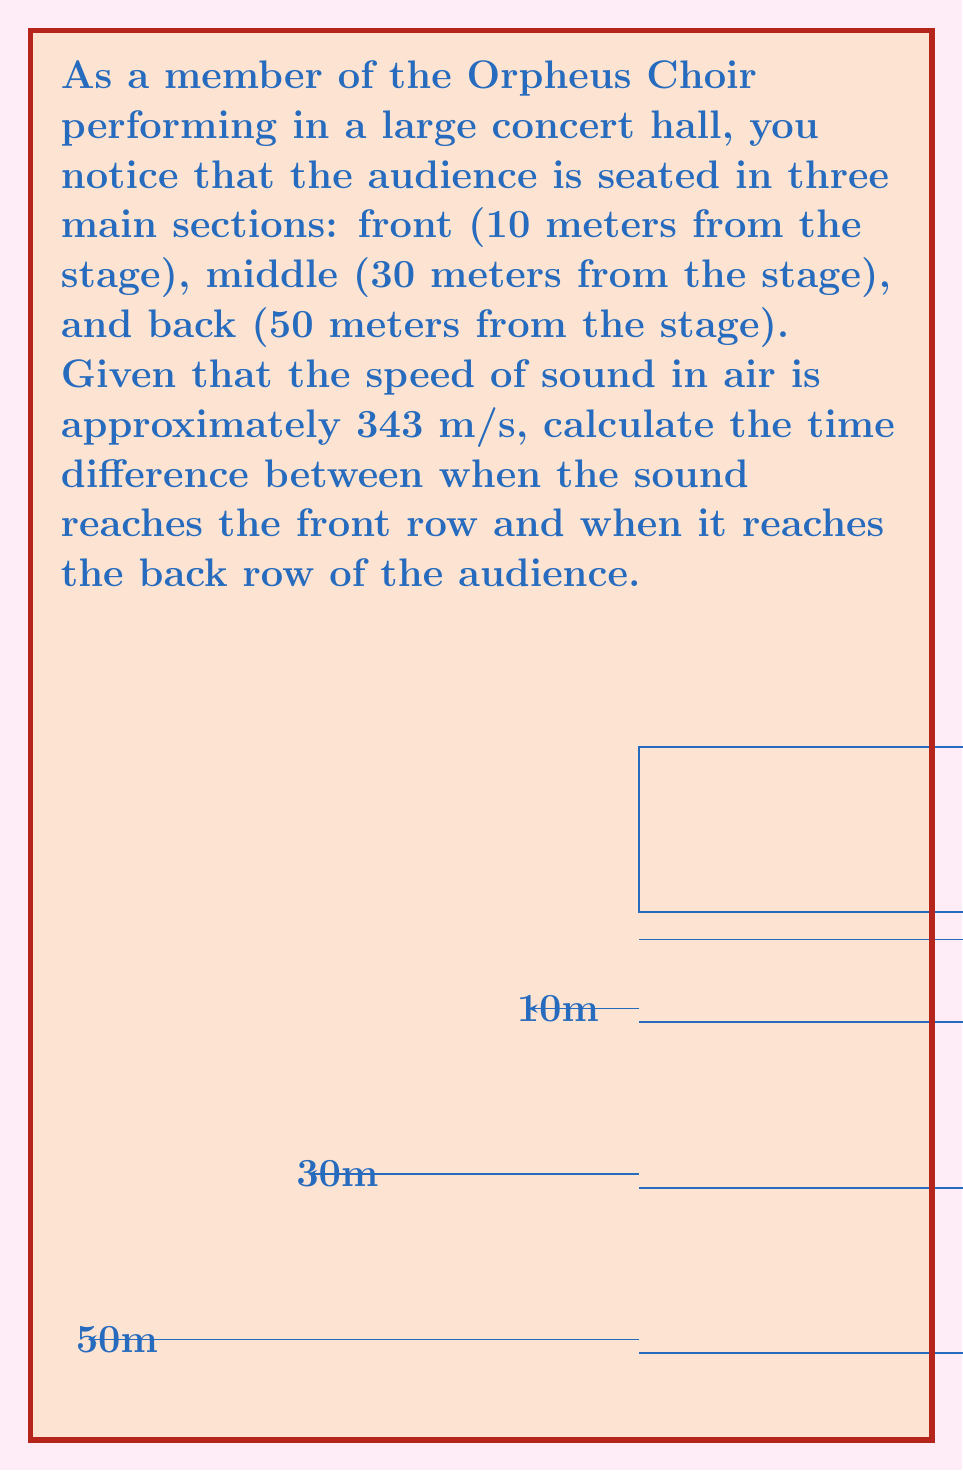Can you solve this math problem? Let's approach this step-by-step:

1) We need to calculate the time it takes for sound to travel from the stage to the back row and subtract the time it takes to reach the front row.

2) The formula for time is: $t = \frac{d}{v}$, where $t$ is time, $d$ is distance, and $v$ is velocity (speed of sound in this case).

3) For the front row:
   $t_{\text{front}} = \frac{10\text{ m}}{343\text{ m/s}} \approx 0.0291\text{ s}$

4) For the back row:
   $t_{\text{back}} = \frac{50\text{ m}}{343\text{ m/s}} \approx 0.1457\text{ s}$

5) The time difference is:
   $\Delta t = t_{\text{back}} - t_{\text{front}} = 0.1457\text{ s} - 0.0291\text{ s} = 0.1166\text{ s}$

6) Converting to milliseconds for a more practical unit:
   $0.1166\text{ s} \times 1000 = 116.6\text{ ms}$

Therefore, the sound reaches the back row approximately 116.6 milliseconds after it reaches the front row.
Answer: 116.6 ms 